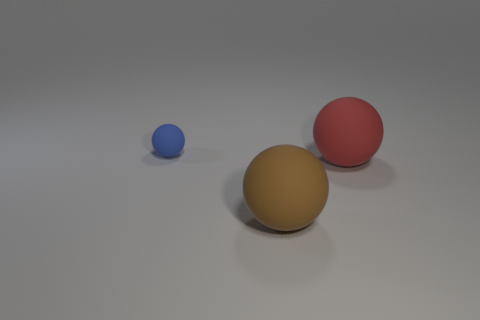Add 1 brown spheres. How many objects exist? 4 Subtract all brown matte spheres. Subtract all large purple metal cubes. How many objects are left? 2 Add 3 rubber objects. How many rubber objects are left? 6 Add 3 matte things. How many matte things exist? 6 Subtract 0 red cubes. How many objects are left? 3 